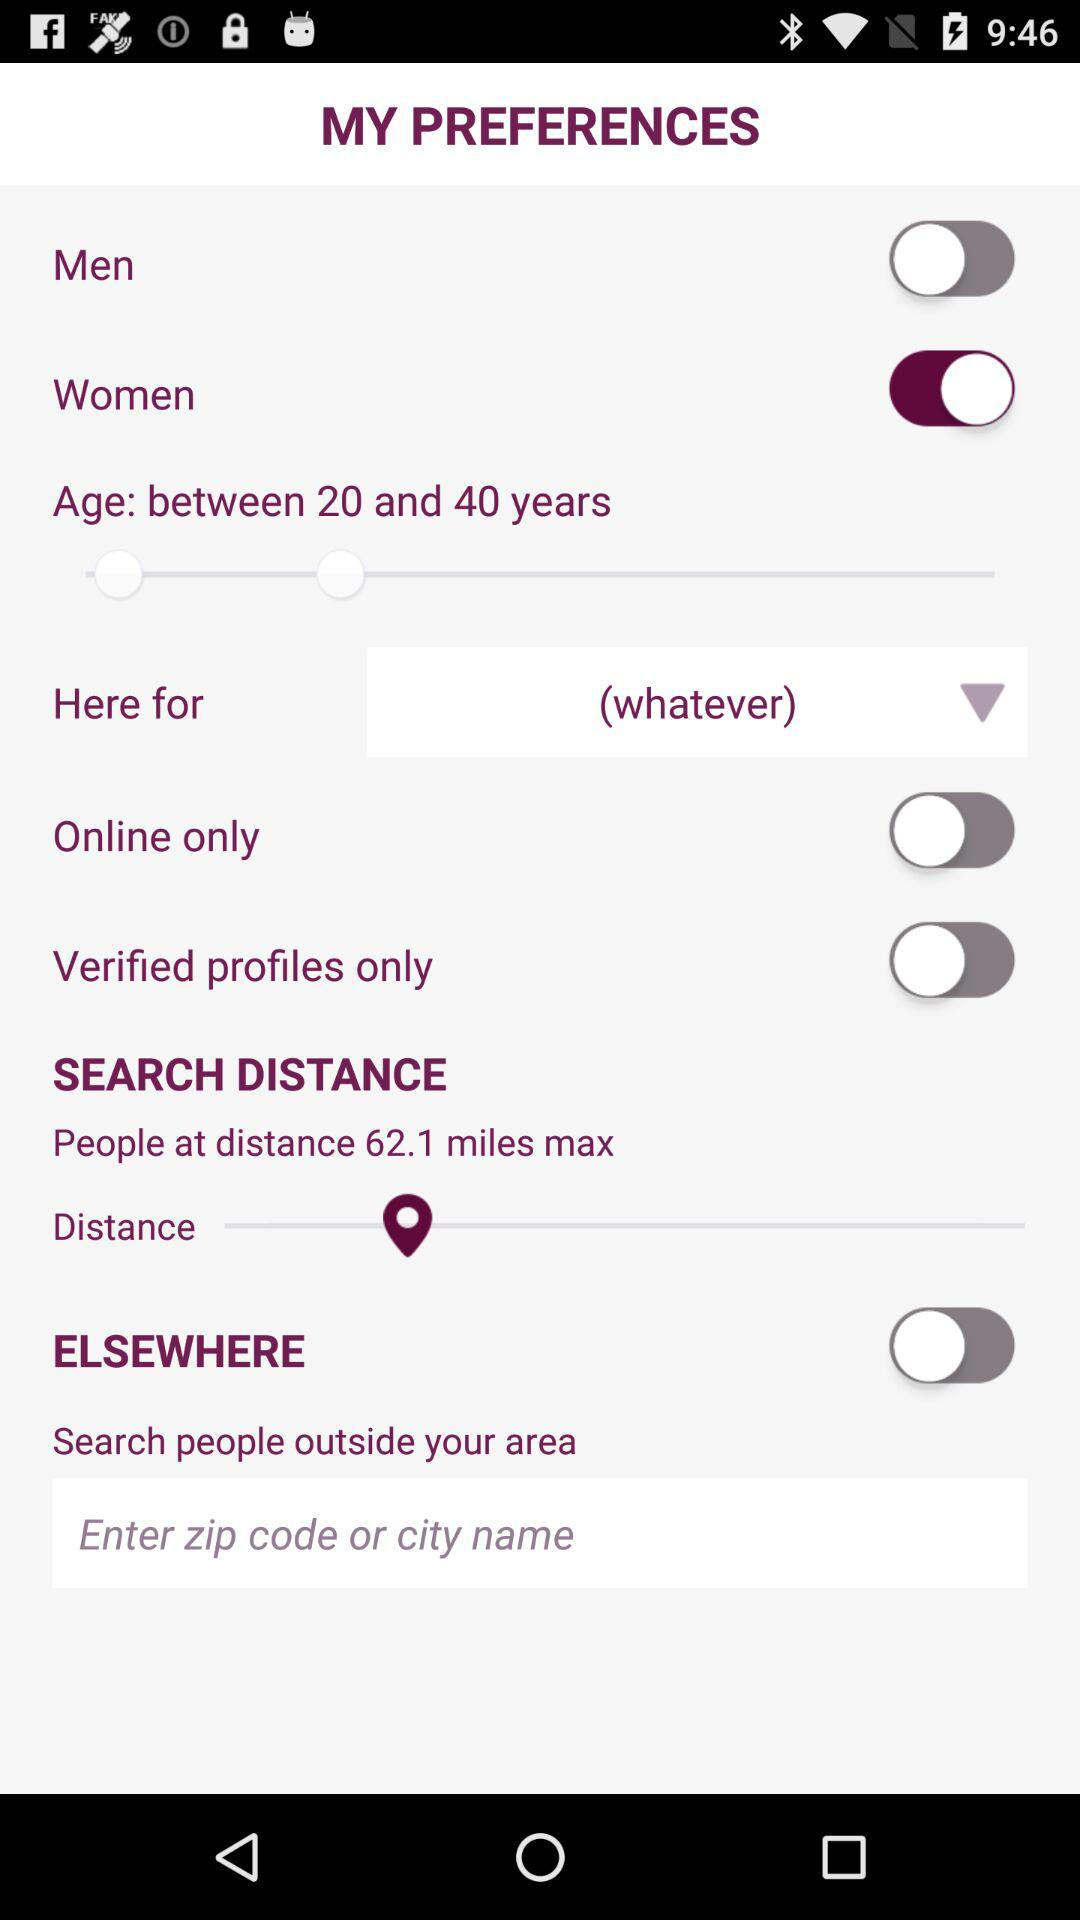What option is selected for "Here for"? The selected option is whatever. 